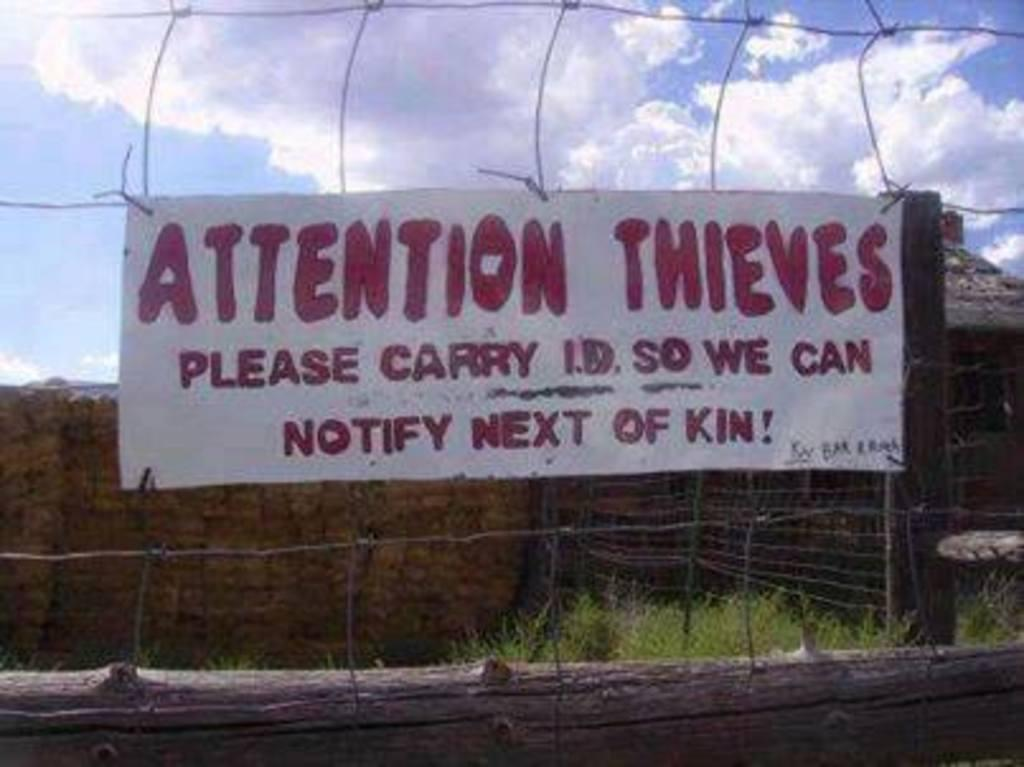What type of structure can be seen in the image? There is a fence in the image. What other object is present in the image? There is a board in the image. What is supporting the fence in the image? There is a wooden log under the fence. What can be seen behind the board in the image? There is a wall visible behind the board. What part of the natural environment is visible in the image? The sky is visible in the image. How many kittens are sitting on the fence in the image? There are no kittens present in the image; it only features a fence, a board, a wooden log, a wall, and the sky. 